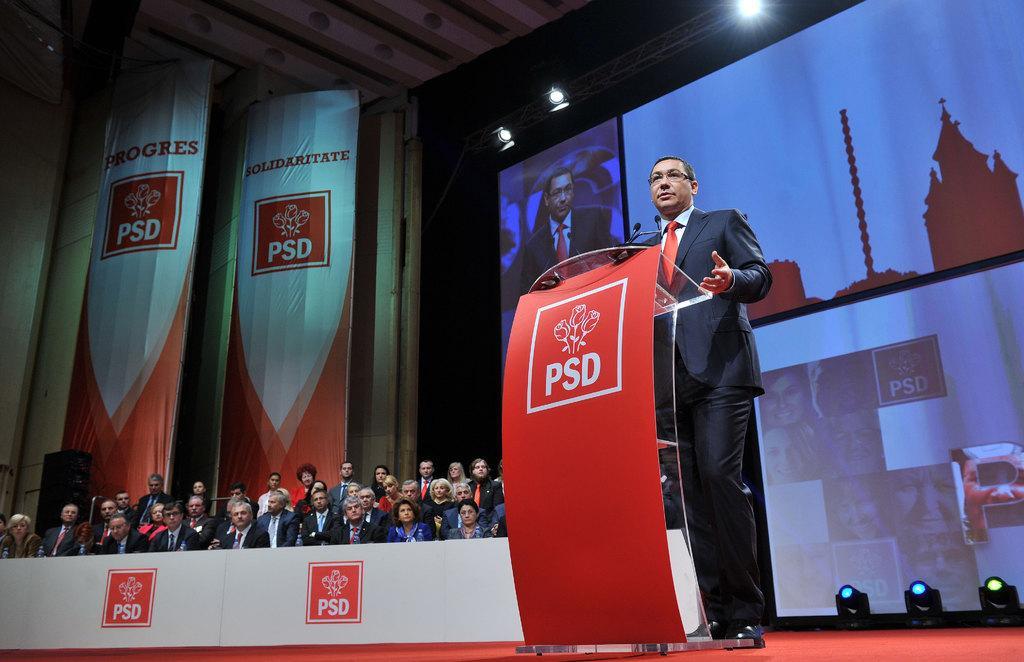How would you summarize this image in a sentence or two? In this picture we can see group of people, few are seated and a man is standing, in front of him we can find a podium and microphones, in the background we can see few hoardings and lights. 